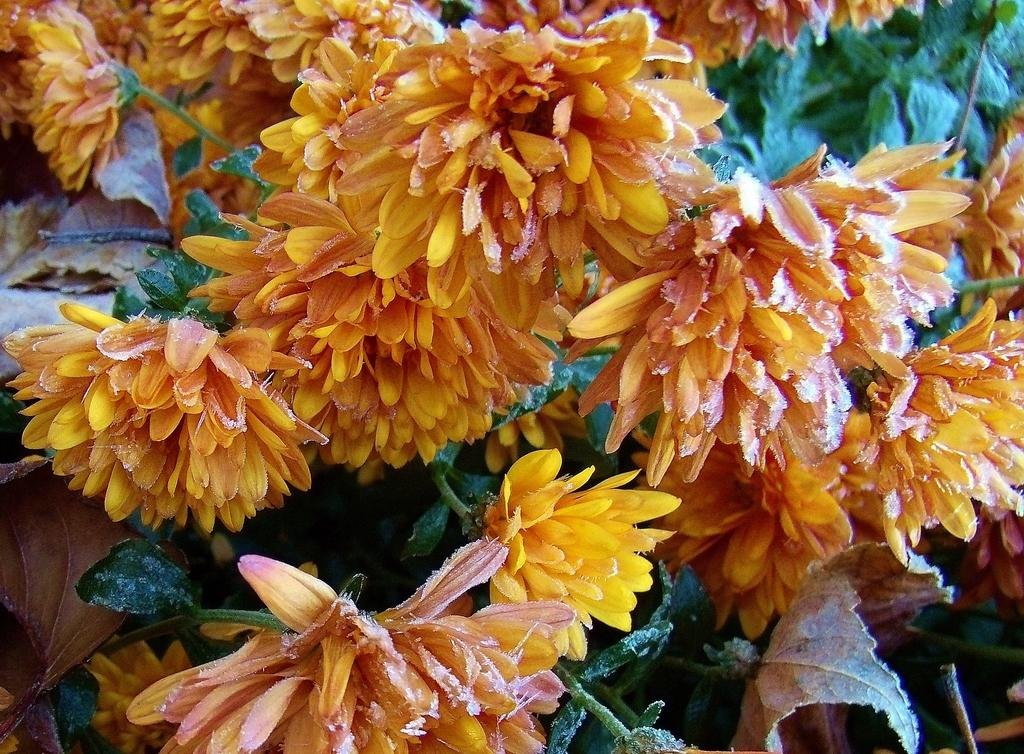What color are the flowers in the image? The flowers in the image are yellow. What are the flowers growing on? The flowers are on plants. What color are the plants in the background of the image? The plants in the background of the image are green. What type of locket can be seen hanging from the flowers in the image? There is no locket present in the image; it only features yellow flowers on plants and green plants in the background. 